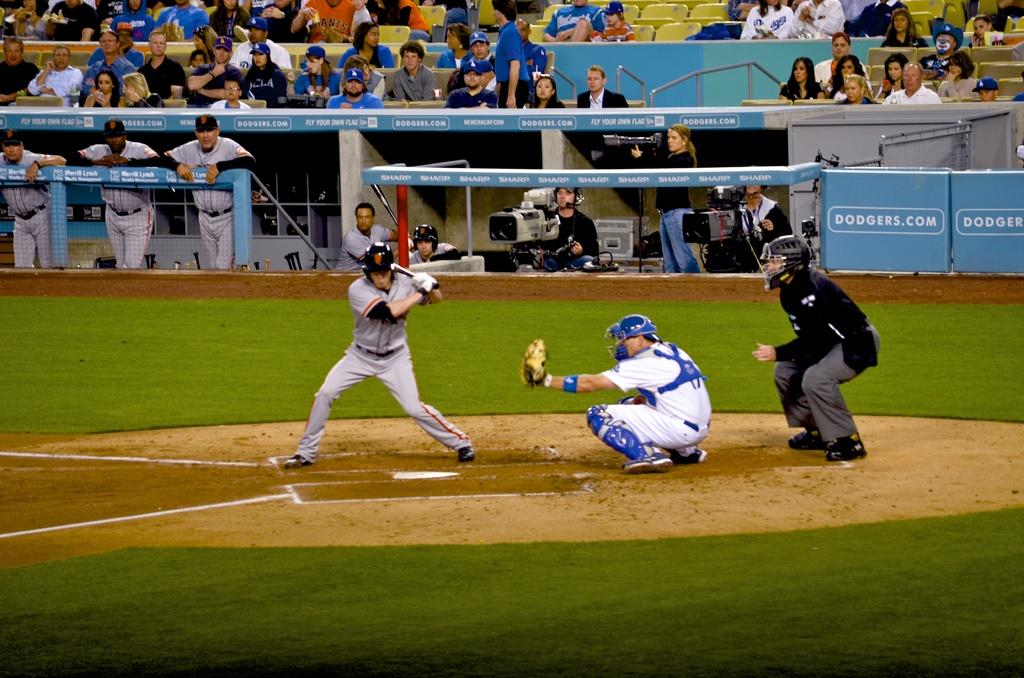<image>
Summarize the visual content of the image. A baseball player is getting ready to swing at a pitch in a stadium that says Dodgers.com. 